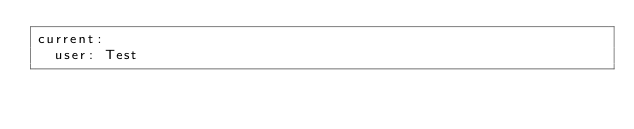<code> <loc_0><loc_0><loc_500><loc_500><_YAML_>current:
  user: Test</code> 